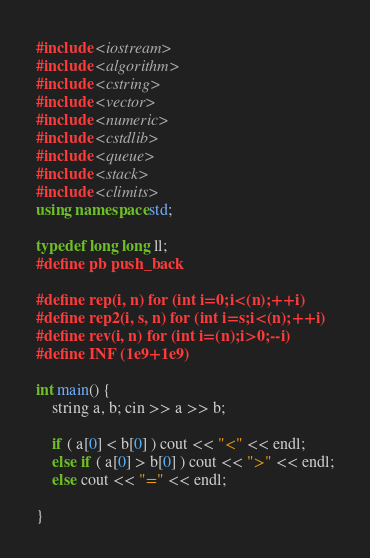Convert code to text. <code><loc_0><loc_0><loc_500><loc_500><_C++_>#include <iostream>
#include <algorithm>
#include <cstring>
#include <vector>
#include <numeric>
#include <cstdlib>
#include <queue>
#include <stack>
#include <climits>
using namespace std;

typedef long long ll;
#define pb push_back

#define rep(i, n) for (int i=0;i<(n);++i)
#define rep2(i, s, n) for (int i=s;i<(n);++i)
#define rev(i, n) for (int i=(n);i>0;--i)
#define INF (1e9+1e9)

int main() {
    string a, b; cin >> a >> b;

    if ( a[0] < b[0] ) cout << "<" << endl;
    else if ( a[0] > b[0] ) cout << ">" << endl;
    else cout << "=" << endl;
    
}</code> 